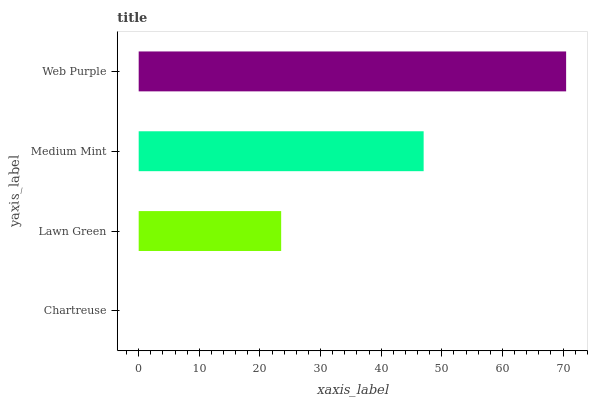Is Chartreuse the minimum?
Answer yes or no. Yes. Is Web Purple the maximum?
Answer yes or no. Yes. Is Lawn Green the minimum?
Answer yes or no. No. Is Lawn Green the maximum?
Answer yes or no. No. Is Lawn Green greater than Chartreuse?
Answer yes or no. Yes. Is Chartreuse less than Lawn Green?
Answer yes or no. Yes. Is Chartreuse greater than Lawn Green?
Answer yes or no. No. Is Lawn Green less than Chartreuse?
Answer yes or no. No. Is Medium Mint the high median?
Answer yes or no. Yes. Is Lawn Green the low median?
Answer yes or no. Yes. Is Chartreuse the high median?
Answer yes or no. No. Is Chartreuse the low median?
Answer yes or no. No. 